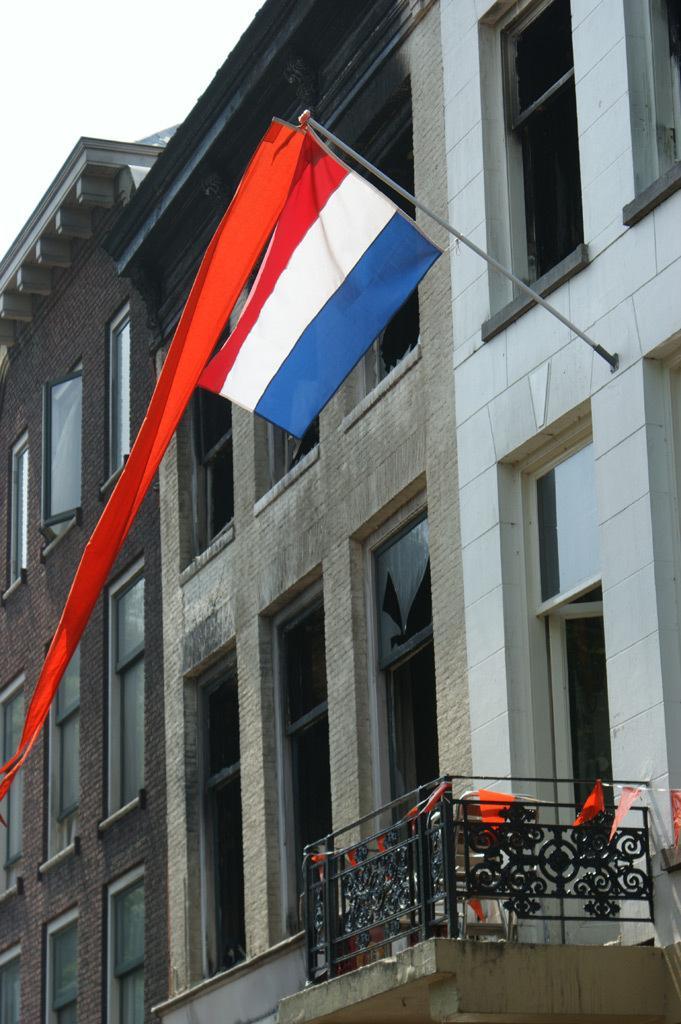In one or two sentences, can you explain what this image depicts? In the foreground of the image we can see a balcony and flags. In the middle of the image we can see building, flag and rod. On the top of the image we can see the sky and top edge of the building. 